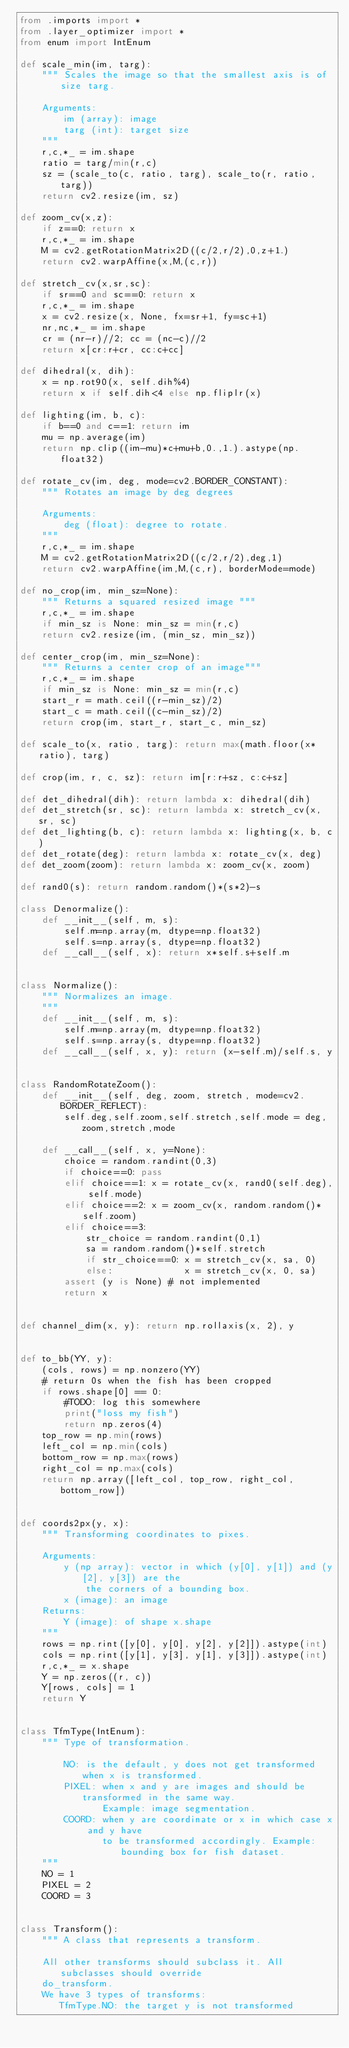Convert code to text. <code><loc_0><loc_0><loc_500><loc_500><_Python_>from .imports import *
from .layer_optimizer import *
from enum import IntEnum

def scale_min(im, targ):
    """ Scales the image so that the smallest axis is of size targ.

    Arguments:
        im (array): image
        targ (int): target size
    """
    r,c,*_ = im.shape
    ratio = targ/min(r,c)
    sz = (scale_to(c, ratio, targ), scale_to(r, ratio, targ))
    return cv2.resize(im, sz)

def zoom_cv(x,z):
    if z==0: return x
    r,c,*_ = im.shape
    M = cv2.getRotationMatrix2D((c/2,r/2),0,z+1.)
    return cv2.warpAffine(x,M,(c,r))

def stretch_cv(x,sr,sc):
    if sr==0 and sc==0: return x
    r,c,*_ = im.shape
    x = cv2.resize(x, None, fx=sr+1, fy=sc+1)
    nr,nc,*_ = im.shape
    cr = (nr-r)//2; cc = (nc-c)//2
    return x[cr:r+cr, cc:c+cc]

def dihedral(x, dih):
    x = np.rot90(x, self.dih%4)
    return x if self.dih<4 else np.fliplr(x)

def lighting(im, b, c):
    if b==0 and c==1: return im
    mu = np.average(im)
    return np.clip((im-mu)*c+mu+b,0.,1.).astype(np.float32)

def rotate_cv(im, deg, mode=cv2.BORDER_CONSTANT):
    """ Rotates an image by deg degrees

    Arguments:
        deg (float): degree to rotate.
    """
    r,c,*_ = im.shape
    M = cv2.getRotationMatrix2D((c/2,r/2),deg,1)
    return cv2.warpAffine(im,M,(c,r), borderMode=mode)

def no_crop(im, min_sz=None):
    """ Returns a squared resized image """
    r,c,*_ = im.shape
    if min_sz is None: min_sz = min(r,c)
    return cv2.resize(im, (min_sz, min_sz))

def center_crop(im, min_sz=None):
    """ Returns a center crop of an image"""
    r,c,*_ = im.shape
    if min_sz is None: min_sz = min(r,c)
    start_r = math.ceil((r-min_sz)/2)
    start_c = math.ceil((c-min_sz)/2)
    return crop(im, start_r, start_c, min_sz)

def scale_to(x, ratio, targ): return max(math.floor(x*ratio), targ)

def crop(im, r, c, sz): return im[r:r+sz, c:c+sz]

def det_dihedral(dih): return lambda x: dihedral(dih)
def det_stretch(sr, sc): return lambda x: stretch_cv(x, sr, sc)
def det_lighting(b, c): return lambda x: lighting(x, b, c)
def det_rotate(deg): return lambda x: rotate_cv(x, deg)
def det_zoom(zoom): return lambda x: zoom_cv(x, zoom)

def rand0(s): return random.random()*(s*2)-s

class Denormalize():
    def __init__(self, m, s):
        self.m=np.array(m, dtype=np.float32)
        self.s=np.array(s, dtype=np.float32)
    def __call__(self, x): return x*self.s+self.m


class Normalize():
    """ Normalizes an image.
    """
    def __init__(self, m, s):
        self.m=np.array(m, dtype=np.float32)
        self.s=np.array(s, dtype=np.float32)
    def __call__(self, x, y): return (x-self.m)/self.s, y


class RandomRotateZoom():
    def __init__(self, deg, zoom, stretch, mode=cv2.BORDER_REFLECT):
        self.deg,self.zoom,self.stretch,self.mode = deg,zoom,stretch,mode

    def __call__(self, x, y=None):
        choice = random.randint(0,3)
        if choice==0: pass
        elif choice==1: x = rotate_cv(x, rand0(self.deg), self.mode)
        elif choice==2: x = zoom_cv(x, random.random()*self.zoom)
        elif choice==3:
            str_choice = random.randint(0,1)
            sa = random.random()*self.stretch
            if str_choice==0: x = stretch_cv(x, sa, 0)
            else:             x = stretch_cv(x, 0, sa)
        assert (y is None) # not implemented
        return x


def channel_dim(x, y): return np.rollaxis(x, 2), y


def to_bb(YY, y):
    (cols, rows) = np.nonzero(YY)
    # return 0s when the fish has been cropped
    if rows.shape[0] == 0:
        #TODO: log this somewhere
        print("loss my fish")
        return np.zeros(4)
    top_row = np.min(rows)
    left_col = np.min(cols)
    bottom_row = np.max(rows)
    right_col = np.max(cols)
    return np.array([left_col, top_row, right_col, bottom_row])


def coords2px(y, x):
    """ Transforming coordinates to pixes.

    Arguments:
        y (np array): vector in which (y[0], y[1]) and (y[2], y[3]) are the
            the corners of a bounding box.
        x (image): an image
    Returns:
        Y (image): of shape x.shape
    """
    rows = np.rint([y[0], y[0], y[2], y[2]]).astype(int)
    cols = np.rint([y[1], y[3], y[1], y[3]]).astype(int)
    r,c,*_ = x.shape
    Y = np.zeros((r, c))
    Y[rows, cols] = 1
    return Y


class TfmType(IntEnum):
    """ Type of transformation.

        NO: is the default, y does not get transformed when x is transformed.
        PIXEL: when x and y are images and should be transformed in the same way.
               Example: image segmentation.
        COORD: when y are coordinate or x in which case x and y have
               to be transformed accordingly. Example: bounding box for fish dataset.
    """
    NO = 1
    PIXEL = 2
    COORD = 3


class Transform():
    """ A class that represents a transform.

    All other transforms should subclass it. All subclasses should override
    do_transform.
    We have 3 types of transforms:
       TfmType.NO: the target y is not transformed</code> 